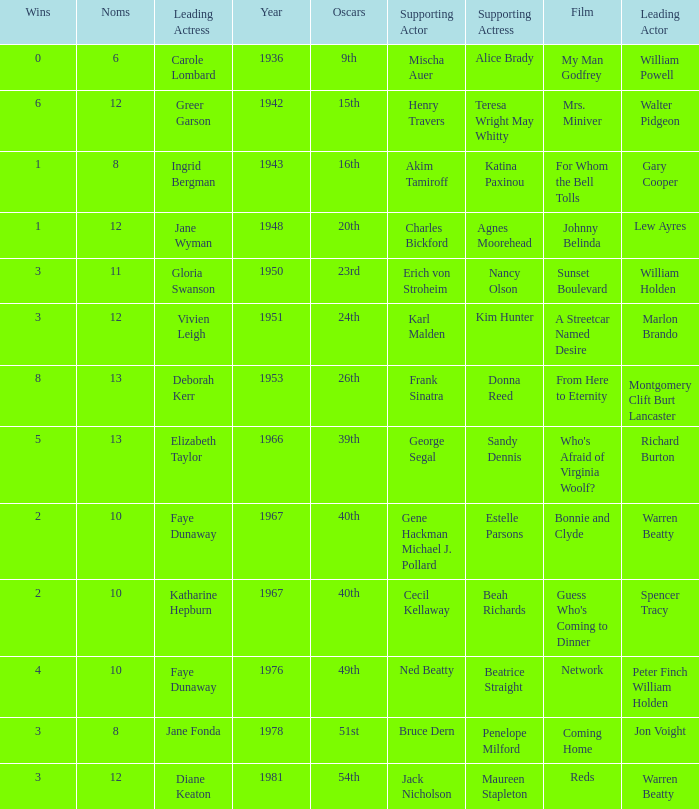Who was the supporting actress in 1943? Katina Paxinou. 